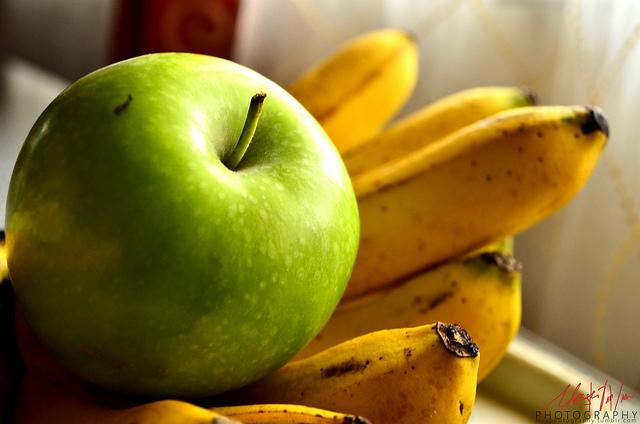What kinds of fruits can be seen?
Keep it brief. Apple and bananas. Are the bananas ripe yet?
Give a very brief answer. Yes. What kind of apple is seen?
Concise answer only. Granny smith. 